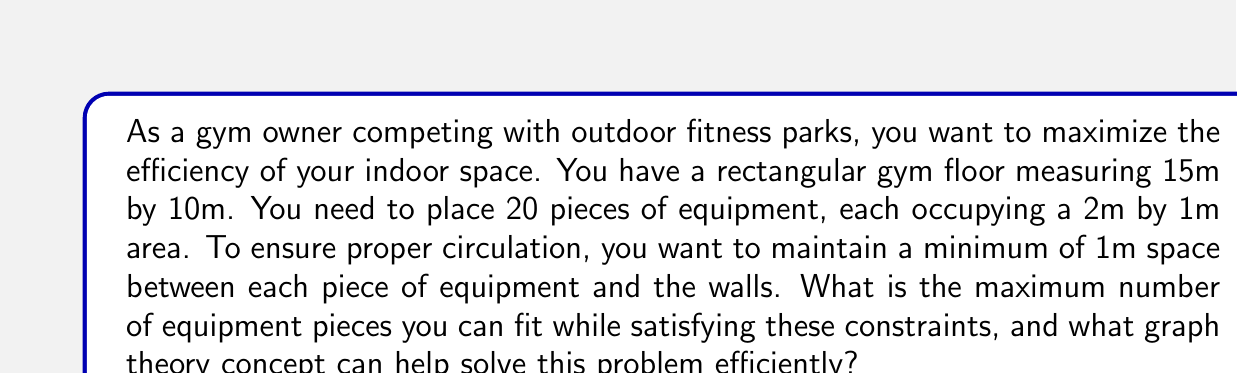Could you help me with this problem? To solve this problem, we can use the concept of maximum independent set in graph theory. Here's how we can approach it:

1. First, let's calculate the usable area:
   - Total area: $15m \times 10m = 150m^2$
   - Usable area: $(15m - 2m) \times (10m - 2m) = 13m \times 8m = 104m^2$

2. Each piece of equipment occupies:
   $2m \times 1m = 2m^2$

3. We need to consider the 1m space around each equipment. This means each equipment effectively occupies:
   $(2m + 2m) \times (1m + 2m) = 4m \times 3m = 12m^2$

4. Now, we can represent this as a graph problem:
   - Each possible equipment placement is a vertex.
   - Two vertices are connected by an edge if their corresponding placements overlap.

5. Finding the maximum number of equipment pieces that can fit is equivalent to finding the maximum independent set in this graph.

6. While finding the exact maximum independent set is NP-hard, we can estimate an upper bound:
   $\text{Upper bound} = \lfloor \frac{\text{Usable area}}{\text{Effective area per equipment}} \rfloor$
   $= \lfloor \frac{104m^2}{12m^2} \rfloor = \lfloor 8.67 \rfloor = 8$

7. This upper bound of 8 is likely close to the actual maximum, as it doesn't account for some edge effects and optimal arrangement.

The maximum independent set approach is more efficient than brute-force checking all possible arrangements, especially for larger spaces or more complex constraints.
Answer: The maximum number of equipment pieces that can fit is approximately 8, and the graph theory concept that can help solve this problem efficiently is the maximum independent set. 